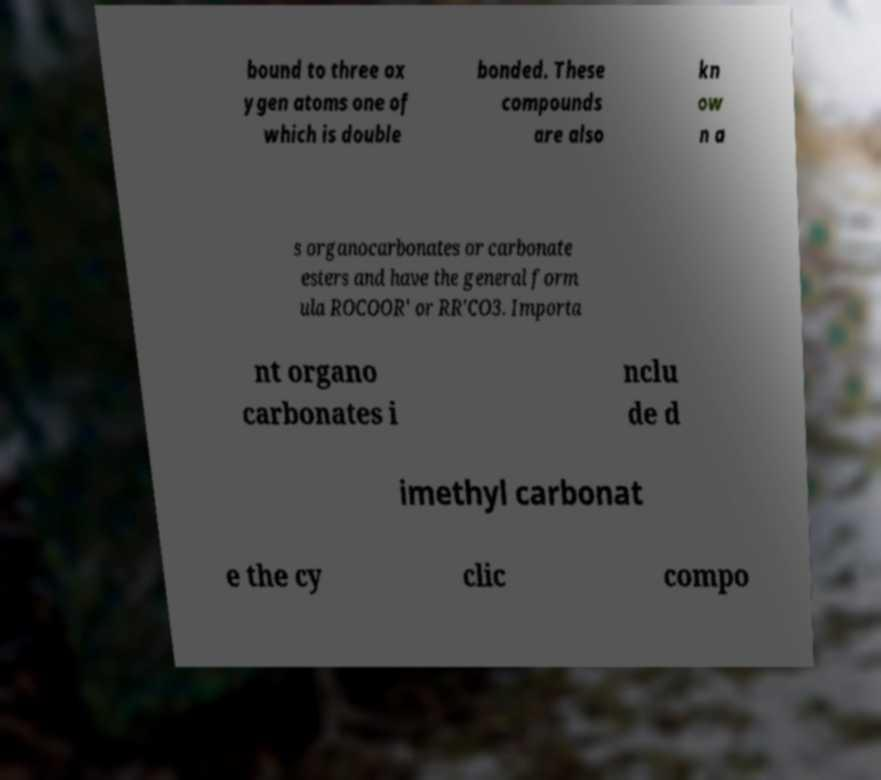Can you accurately transcribe the text from the provided image for me? bound to three ox ygen atoms one of which is double bonded. These compounds are also kn ow n a s organocarbonates or carbonate esters and have the general form ula ROCOOR′ or RR′CO3. Importa nt organo carbonates i nclu de d imethyl carbonat e the cy clic compo 